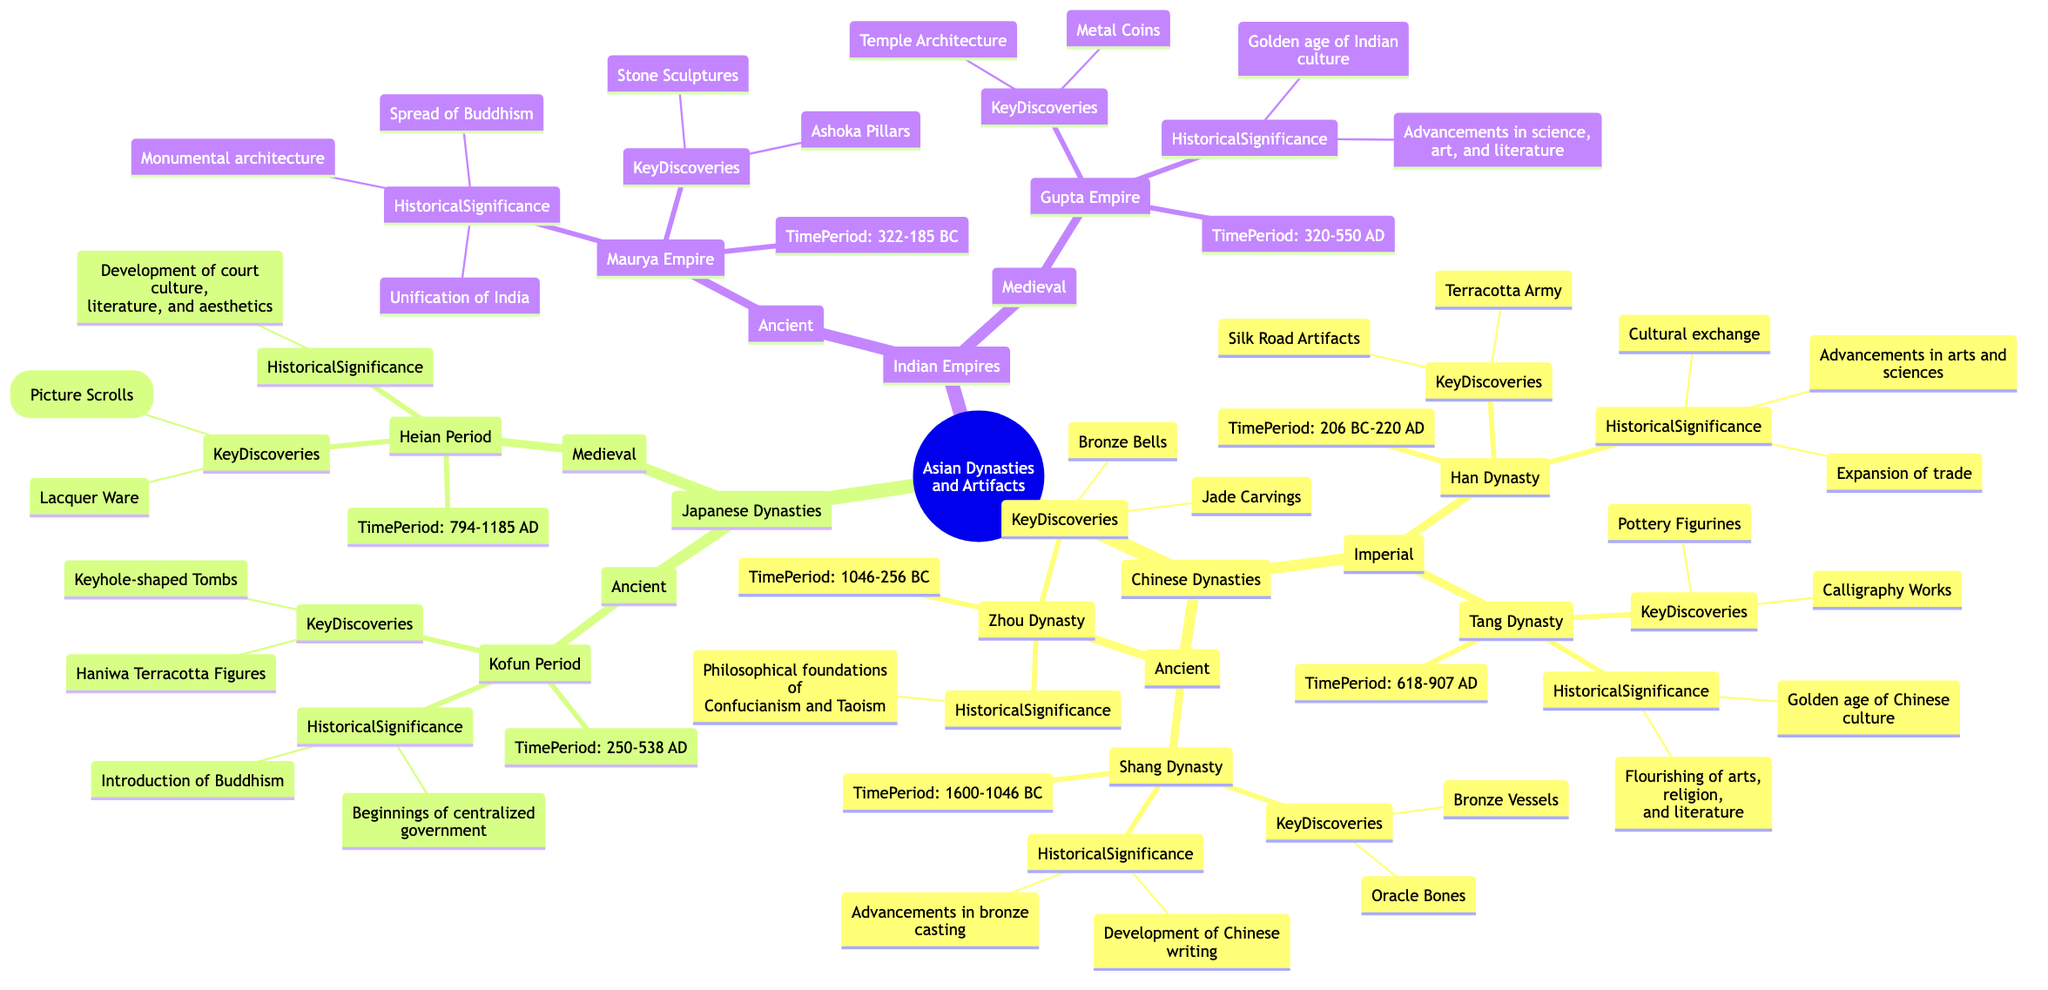What is the time period of the Shang Dynasty? The Shang Dynasty's time period is specified under "Ancient" within the "Chinese Dynasties" section. It states that the Shang Dynasty lasted from 1600 to 1046 BC.
Answer: 1600-1046 BC What key discoveries are associated with the Tang Dynasty? To find the key discoveries of the Tang Dynasty, we refer to the section under "Imperial" in the "Chinese Dynasties" category. The diagram lists "Pottery Figurines" and "Calligraphy Works" as key discoveries.
Answer: Pottery Figurines, Calligraphy Works Which empire is noted for the Ashoka Pillars? The Ashoka Pillars are associated with the Maurya Empire. Looking under "Indian Empires" in the "Ancient" section confirms that the key discoveries of this empire include the Ashoka Pillars.
Answer: Maurya Empire What is the historical significance of the Gupta Empire? We identify the Gupta Empire under "Indian Empires" in the "Medieval" section and check its historical significance. The diagram states that it marked the "Golden age of Indian culture" and saw "advancements in science, art, and literature."
Answer: Golden age of Indian culture What historical event does the Kofun Period represent? The Kofun Period is found in the "Japanese Dynasties" under "Ancient" and is characterized by introducing Buddhism and the beginnings of centralized government, which is noted in its historical significance.
Answer: Introduction of Buddhism What characterizes the Zhou Dynasty's historical significance? The diagram specifies the historical significance of the Zhou Dynasty as "Philosophical foundations of Confucianism and Taoism." This characterizes its impact and influence during and beyond its time.
Answer: Philosophical foundations of Confucianism and Taoism How many periods are listed under Japanese Dynasties? The diagram breaks down the Japanese Dynasties into two main periods: "Ancient” (featuring the Kofun Period) and "Medieval" (featuring the Heian Period). The count is 2.
Answer: 2 Name one key discovery from the Han Dynasty. Looking at the Han Dynasty's section in "Chinese Dynasties," we can identify "Silk Road Artifacts" as a highlighted key discovery under this empire.
Answer: Silk Road Artifacts What is the time span of the Gupta Empire? The time span of the Gupta Empire can be found in the "Medieval" section under "Indian Empires." The diagram presents the time period as 320 to 550 AD.
Answer: 320-550 AD 